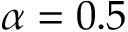<formula> <loc_0><loc_0><loc_500><loc_500>\alpha = 0 . 5</formula> 